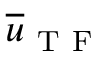Convert formula to latex. <formula><loc_0><loc_0><loc_500><loc_500>\overline { u } _ { T F }</formula> 